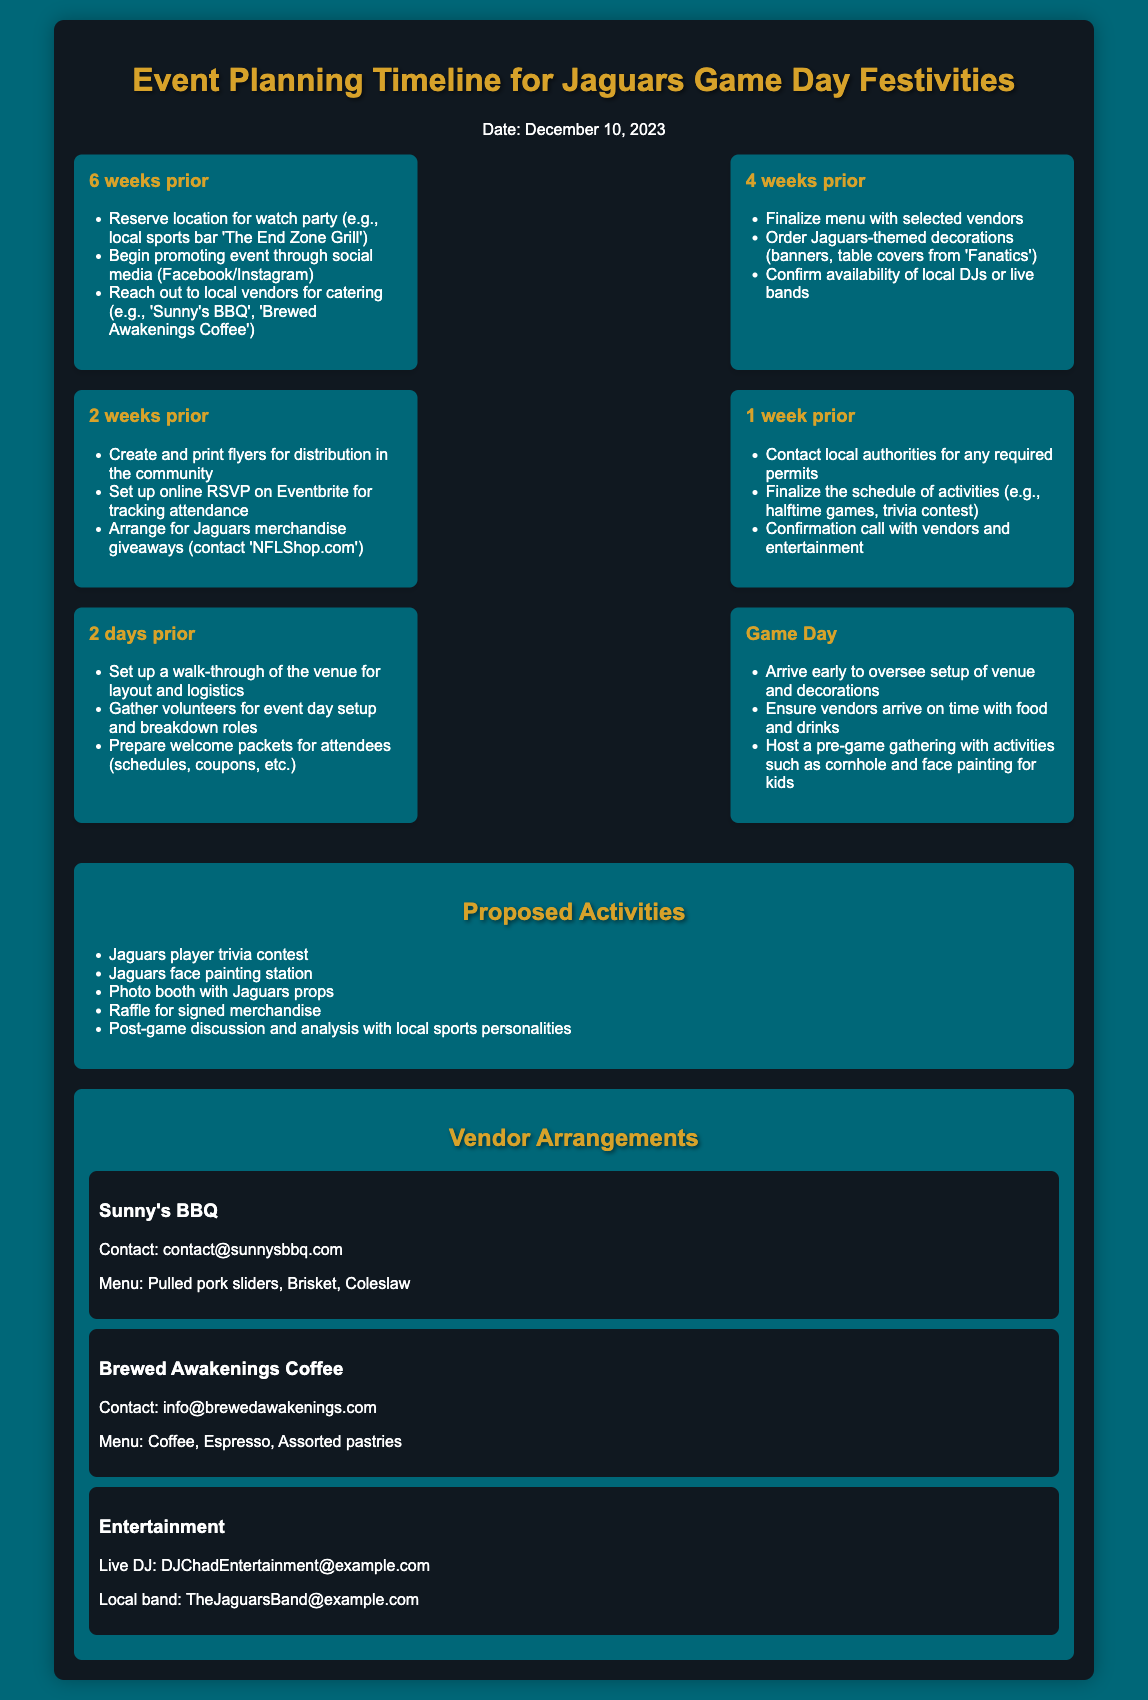What is the event date? The event date is explicitly stated in the document, which is December 10, 2023.
Answer: December 10, 2023 Who is the entertainment vendor mentioned? The entertainment vendors are listed in the vendor arrangements, including a live DJ and a local band.
Answer: DJChadEntertainment@example.com What activity involves a contest related to Jaguars players? Activities are listed in the proposed activities section, and one of them is related to trivia about Jaguars players.
Answer: Jaguars player trivia contest How many weeks prior to the event should the location be reserved? The timeline item specifies that the location should be reserved six weeks prior to the event.
Answer: 6 weeks prior What type of food is offered by Sunny's BBQ? The vendor arrangement details the menu for Sunny's BBQ, which includes specific food items.
Answer: Pulled pork sliders What decoration items are ordered four weeks prior? The document outlines that Jaguars-themed decorations like banners are ordered four weeks before the event.
Answer: Jaguars-themed decorations What must be finalized one week before the event? The timeline indicates that the schedule of activities needs to be finalized one week prior to the event.
Answer: Schedule of activities What is one of the proposed activities for kids on Game Day? Among the proposed activities listed, face painting is mentioned specifically for children on Game Day.
Answer: Face painting for kids What should be prepared for attendees two days before the event? The preparation for attendees includes welcome packets, as mentioned in the timeline two days prior.
Answer: Welcome packets 